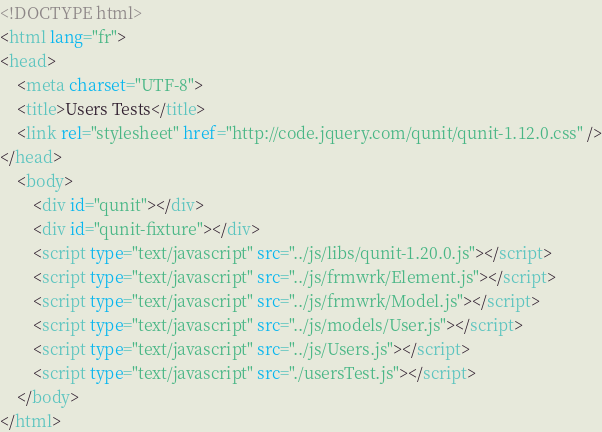Convert code to text. <code><loc_0><loc_0><loc_500><loc_500><_HTML_><!DOCTYPE html>
<html lang="fr">
<head>
    <meta charset="UTF-8">
    <title>Users Tests</title>
    <link rel="stylesheet" href="http://code.jquery.com/qunit/qunit-1.12.0.css" />
</head>
    <body>
        <div id="qunit"></div>
        <div id="qunit-fixture"></div>
        <script type="text/javascript" src="../js/libs/qunit-1.20.0.js"></script>
        <script type="text/javascript" src="../js/frmwrk/Element.js"></script>
        <script type="text/javascript" src="../js/frmwrk/Model.js"></script>
        <script type="text/javascript" src="../js/models/User.js"></script>
        <script type="text/javascript" src="../js/Users.js"></script>
        <script type="text/javascript" src="./usersTest.js"></script>
    </body>
</html></code> 